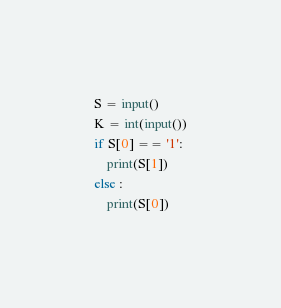Convert code to text. <code><loc_0><loc_0><loc_500><loc_500><_Python_>S = input()
K = int(input())
if S[0] == '1':
    print(S[1])
else :
    print(S[0])</code> 